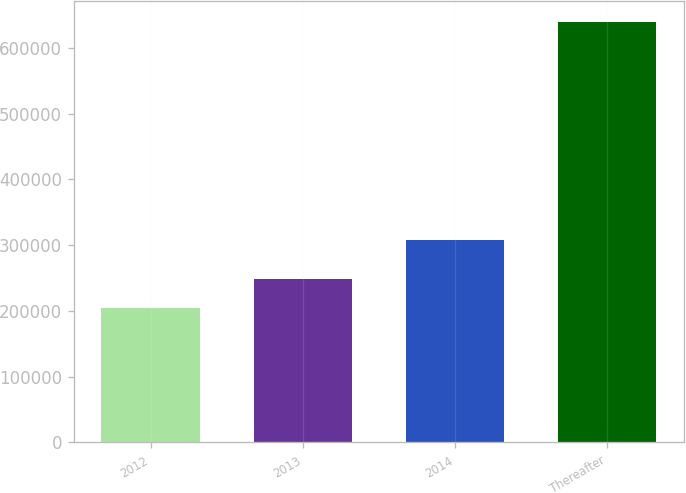Convert chart. <chart><loc_0><loc_0><loc_500><loc_500><bar_chart><fcel>2012<fcel>2013<fcel>2014<fcel>Thereafter<nl><fcel>204607<fcel>248027<fcel>308089<fcel>638807<nl></chart> 